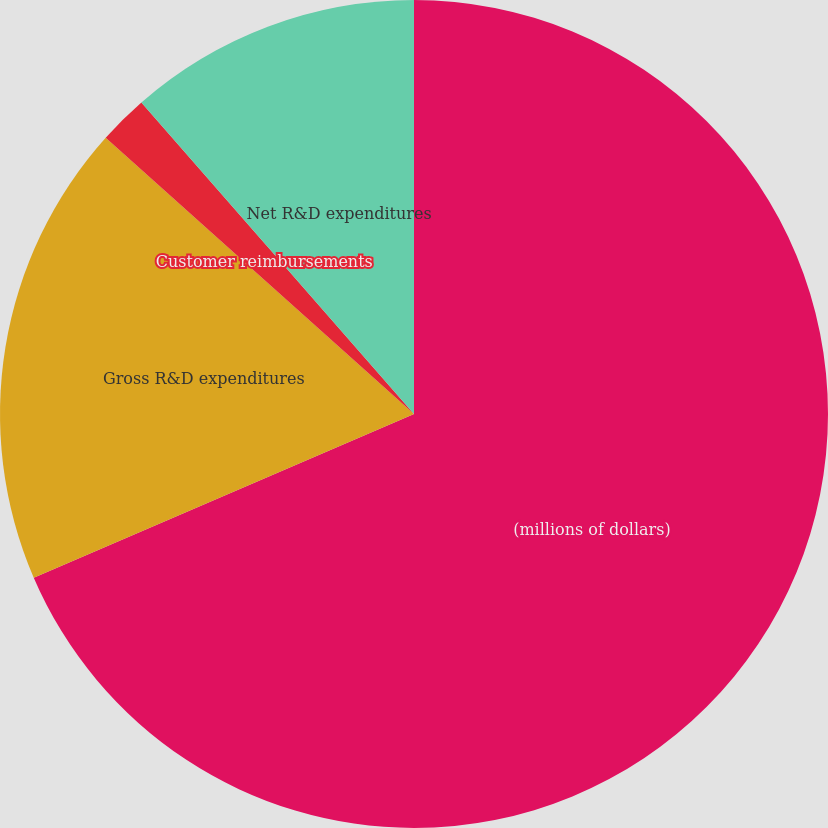Convert chart to OTSL. <chart><loc_0><loc_0><loc_500><loc_500><pie_chart><fcel>(millions of dollars)<fcel>Gross R&D expenditures<fcel>Customer reimbursements<fcel>Net R&D expenditures<nl><fcel>68.53%<fcel>18.1%<fcel>1.93%<fcel>11.44%<nl></chart> 